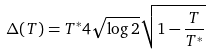Convert formula to latex. <formula><loc_0><loc_0><loc_500><loc_500>\Delta ( T ) = T ^ { * } 4 \sqrt { \log 2 } \sqrt { 1 - \frac { T } { T ^ { * } } }</formula> 